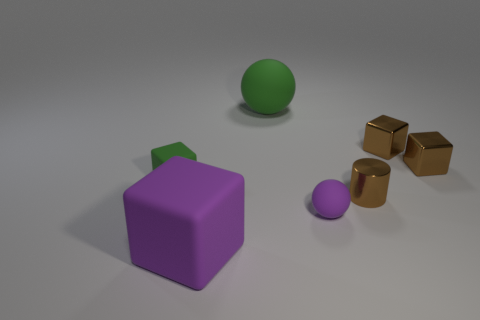Subtract all small rubber cubes. How many cubes are left? 3 Subtract all purple cylinders. How many brown blocks are left? 2 Add 3 cyan metallic blocks. How many objects exist? 10 Subtract 1 blocks. How many blocks are left? 3 Subtract all green cubes. How many cubes are left? 3 Subtract all balls. How many objects are left? 5 Subtract all small green rubber cubes. Subtract all rubber things. How many objects are left? 2 Add 7 large blocks. How many large blocks are left? 8 Add 2 tiny purple shiny cylinders. How many tiny purple shiny cylinders exist? 2 Subtract 0 blue cylinders. How many objects are left? 7 